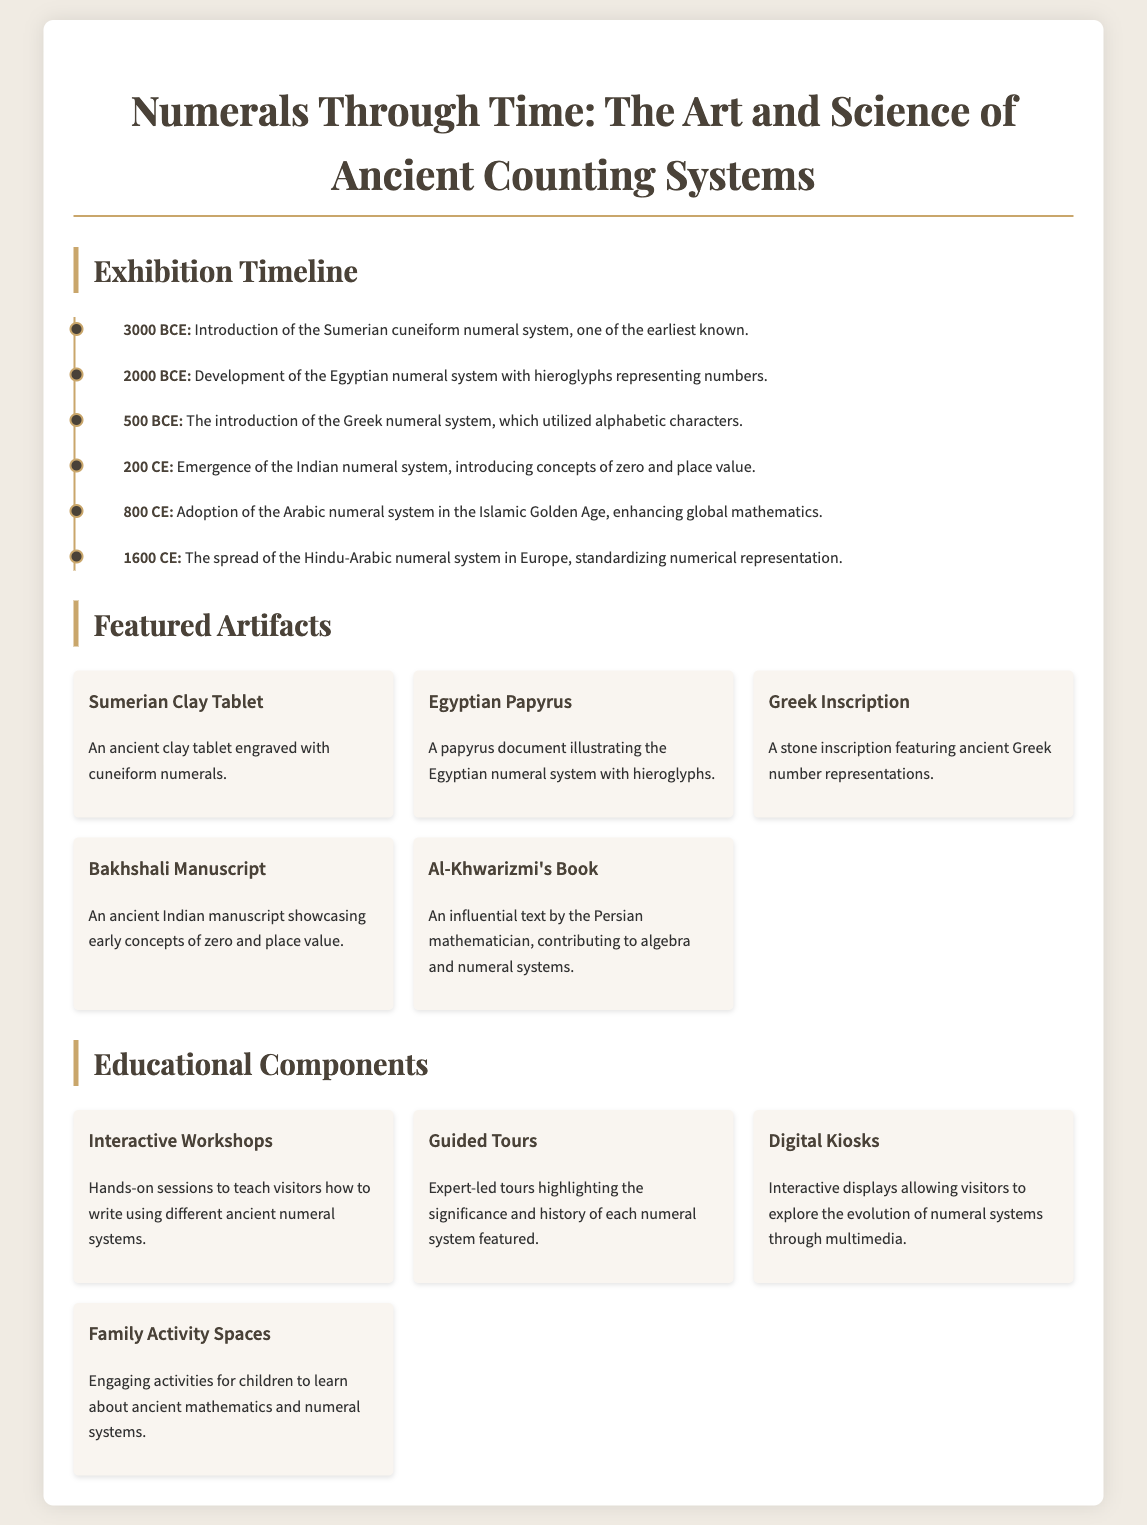What is the title of the exhibition? The title of the exhibition is found at the top of the document and gives an overview of the theme.
Answer: Numerals Through Time: The Art and Science of Ancient Counting Systems What numeral system was introduced in 3000 BCE? The document mentions the specific numeral system introduced during this time in the timeline section.
Answer: Sumerian cuneiform numeral system Which artifact represents the Egyptian numeral system? The document lists artifacts and specifies which one illustrates the Egyptian numeral system with hieroglyphs.
Answer: Egyptian Papyrus What year did the Indian numeral system emerge? The timeline provides the date associated with the emergence of the Indian numeral system.
Answer: 200 CE What is one of the educational components offered in the exhibition? The document details various educational components offered throughout the exhibit, highlighting engagement opportunities.
Answer: Interactive Workshops How many timeline entries are listed? The document includes a specific number of timeline entries detailing the development of numeral systems over centuries.
Answer: 6 What type of manuscript showcases early concepts of zero? The document refers to an artifact specifically showcasing these concepts.
Answer: Bakhshali Manuscript What is the purpose of digital kiosks in the exhibition? The document outlines specific educational components, including the role of digital kiosks in enhancing visitor learning.
Answer: Explore the evolution of numeral systems through multimedia 